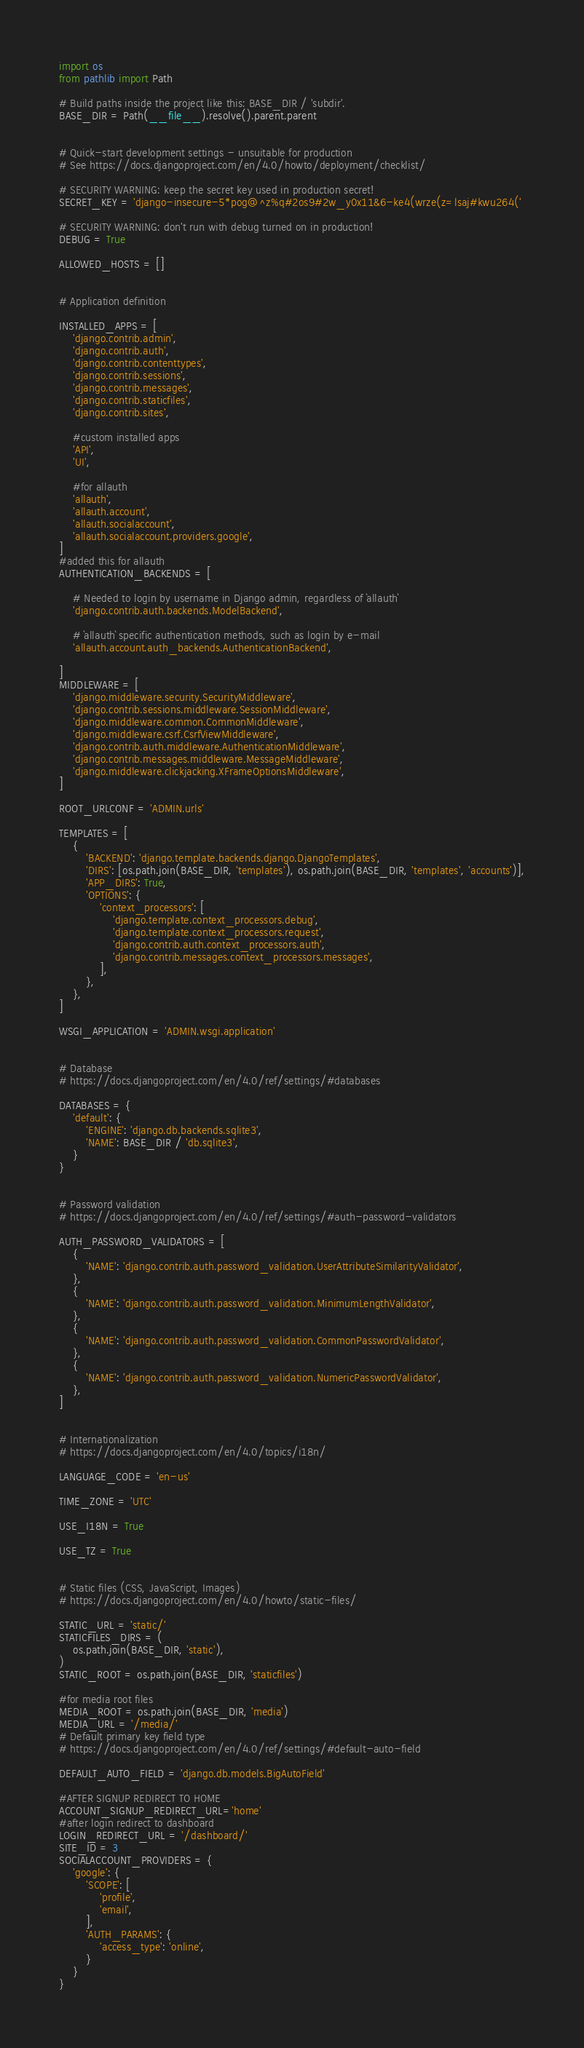Convert code to text. <code><loc_0><loc_0><loc_500><loc_500><_Python_>import os
from pathlib import Path

# Build paths inside the project like this: BASE_DIR / 'subdir'.
BASE_DIR = Path(__file__).resolve().parent.parent


# Quick-start development settings - unsuitable for production
# See https://docs.djangoproject.com/en/4.0/howto/deployment/checklist/

# SECURITY WARNING: keep the secret key used in production secret!
SECRET_KEY = 'django-insecure-5*pog@^z%q#2os9#2w_y0x11&6-ke4(wrze(z=lsaj#kwu264('

# SECURITY WARNING: don't run with debug turned on in production!
DEBUG = True

ALLOWED_HOSTS = []


# Application definition

INSTALLED_APPS = [
    'django.contrib.admin',
    'django.contrib.auth',
    'django.contrib.contenttypes',
    'django.contrib.sessions',
    'django.contrib.messages',
    'django.contrib.staticfiles',
    'django.contrib.sites',
    
    #custom installed apps
    'API',
    'UI',
    
    #for allauth
    'allauth',
    'allauth.account',
    'allauth.socialaccount',
    'allauth.socialaccount.providers.google',
]
#added this for allauth
AUTHENTICATION_BACKENDS = [

    # Needed to login by username in Django admin, regardless of `allauth`
    'django.contrib.auth.backends.ModelBackend',

    # `allauth` specific authentication methods, such as login by e-mail
    'allauth.account.auth_backends.AuthenticationBackend',

]
MIDDLEWARE = [
    'django.middleware.security.SecurityMiddleware',
    'django.contrib.sessions.middleware.SessionMiddleware',
    'django.middleware.common.CommonMiddleware',
    'django.middleware.csrf.CsrfViewMiddleware',
    'django.contrib.auth.middleware.AuthenticationMiddleware',
    'django.contrib.messages.middleware.MessageMiddleware',
    'django.middleware.clickjacking.XFrameOptionsMiddleware',
]

ROOT_URLCONF = 'ADMIN.urls'

TEMPLATES = [
    {
        'BACKEND': 'django.template.backends.django.DjangoTemplates',
        'DIRS': [os.path.join(BASE_DIR, 'templates'), os.path.join(BASE_DIR, 'templates', 'accounts')],
        'APP_DIRS': True,
        'OPTIONS': {
            'context_processors': [
                'django.template.context_processors.debug',
                'django.template.context_processors.request',
                'django.contrib.auth.context_processors.auth',
                'django.contrib.messages.context_processors.messages',
            ],
        },
    },
]

WSGI_APPLICATION = 'ADMIN.wsgi.application'


# Database
# https://docs.djangoproject.com/en/4.0/ref/settings/#databases

DATABASES = {
    'default': {
        'ENGINE': 'django.db.backends.sqlite3',
        'NAME': BASE_DIR / 'db.sqlite3',
    }
}


# Password validation
# https://docs.djangoproject.com/en/4.0/ref/settings/#auth-password-validators

AUTH_PASSWORD_VALIDATORS = [
    {
        'NAME': 'django.contrib.auth.password_validation.UserAttributeSimilarityValidator',
    },
    {
        'NAME': 'django.contrib.auth.password_validation.MinimumLengthValidator',
    },
    {
        'NAME': 'django.contrib.auth.password_validation.CommonPasswordValidator',
    },
    {
        'NAME': 'django.contrib.auth.password_validation.NumericPasswordValidator',
    },
]


# Internationalization
# https://docs.djangoproject.com/en/4.0/topics/i18n/

LANGUAGE_CODE = 'en-us'

TIME_ZONE = 'UTC'

USE_I18N = True

USE_TZ = True


# Static files (CSS, JavaScript, Images)
# https://docs.djangoproject.com/en/4.0/howto/static-files/

STATIC_URL = 'static/'
STATICFILES_DIRS = (
    os.path.join(BASE_DIR, 'static'),
)
STATIC_ROOT = os.path.join(BASE_DIR, 'staticfiles')

#for media root files
MEDIA_ROOT = os.path.join(BASE_DIR, 'media')
MEDIA_URL = '/media/'
# Default primary key field type
# https://docs.djangoproject.com/en/4.0/ref/settings/#default-auto-field

DEFAULT_AUTO_FIELD = 'django.db.models.BigAutoField'

#AFTER SIGNUP REDIRECT TO HOME
ACCOUNT_SIGNUP_REDIRECT_URL='home'
#after login redirect to dashboard
LOGIN_REDIRECT_URL = '/dashboard/'
SITE_ID = 3
SOCIALACCOUNT_PROVIDERS = {
    'google': {
        'SCOPE': [
            'profile',
            'email',
        ],
        'AUTH_PARAMS': {
            'access_type': 'online',
        }
    }
}
</code> 